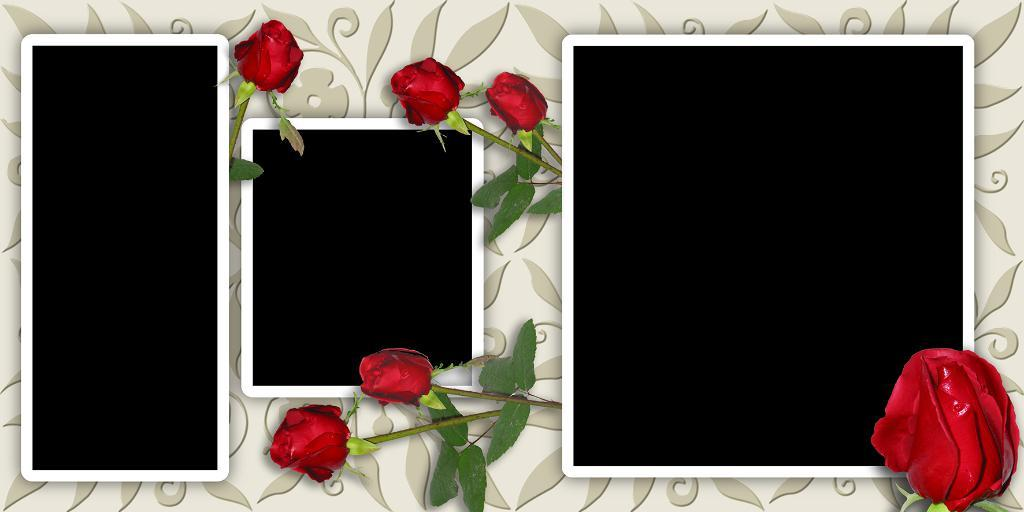What type of flowers are present in the image? The image contains roses. How have the roses been altered in the image? The roses are edited. What other objects are present in the image besides the roses? There are black color cards in the image. Can you describe the appearance of the black color cards? The black color cards have white borders. Where can people be seen playing in the park in the image? There is no park or people playing in the image; it contains roses, edited roses, and black color cards with white borders. How many rings are visible on the fingers of the person in the image? There is no person or rings present in the image. 